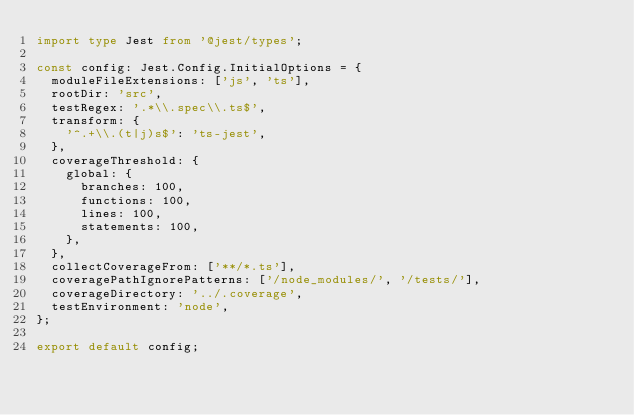<code> <loc_0><loc_0><loc_500><loc_500><_TypeScript_>import type Jest from '@jest/types';

const config: Jest.Config.InitialOptions = {
  moduleFileExtensions: ['js', 'ts'],
  rootDir: 'src',
  testRegex: '.*\\.spec\\.ts$',
  transform: {
    '^.+\\.(t|j)s$': 'ts-jest',
  },
  coverageThreshold: {
    global: {
      branches: 100,
      functions: 100,
      lines: 100,
      statements: 100,
    },
  },
  collectCoverageFrom: ['**/*.ts'],
  coveragePathIgnorePatterns: ['/node_modules/', '/tests/'],
  coverageDirectory: '../.coverage',
  testEnvironment: 'node',
};

export default config;
</code> 